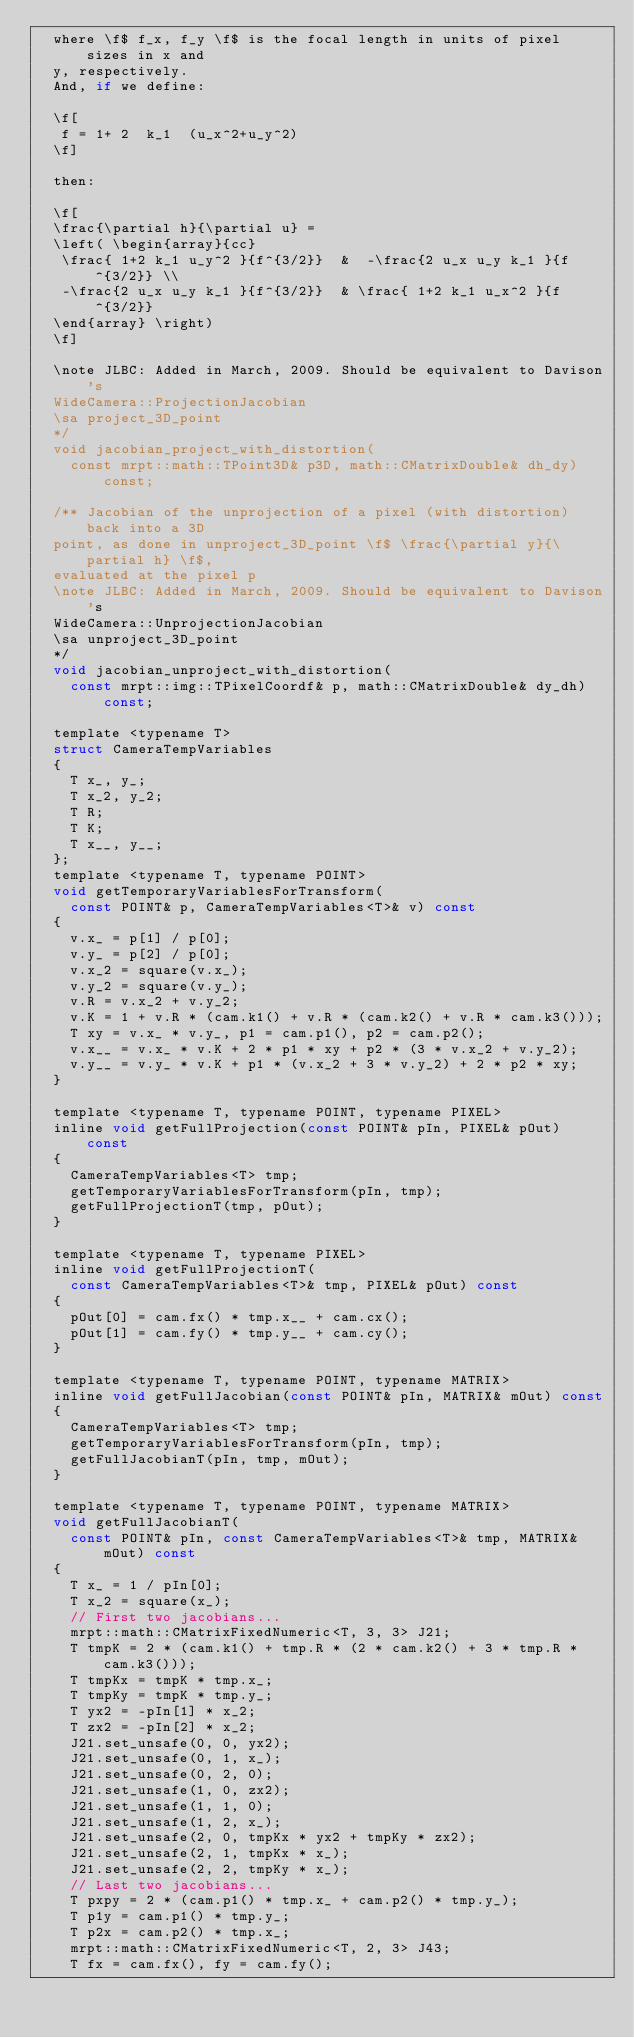Convert code to text. <code><loc_0><loc_0><loc_500><loc_500><_C_>	where \f$ f_x, f_y \f$ is the focal length in units of pixel sizes in x and
	y, respectively.
	And, if we define:

	\f[
	 f = 1+ 2  k_1  (u_x^2+u_y^2)
	\f]

	then:

	\f[
	\frac{\partial h}{\partial u} =
	\left( \begin{array}{cc}
	 \frac{ 1+2 k_1 u_y^2 }{f^{3/2}}  &  -\frac{2 u_x u_y k_1 }{f^{3/2}} \\
	 -\frac{2 u_x u_y k_1 }{f^{3/2}}  & \frac{ 1+2 k_1 u_x^2 }{f^{3/2}}
	\end{array} \right)
	\f]

	\note JLBC: Added in March, 2009. Should be equivalent to Davison's
	WideCamera::ProjectionJacobian
	\sa project_3D_point
	*/
	void jacobian_project_with_distortion(
		const mrpt::math::TPoint3D& p3D, math::CMatrixDouble& dh_dy) const;

	/** Jacobian of the unprojection of a pixel (with distortion) back into a 3D
	point, as done in unproject_3D_point \f$ \frac{\partial y}{\partial h} \f$,
	evaluated at the pixel p
	\note JLBC: Added in March, 2009. Should be equivalent to Davison's
	WideCamera::UnprojectionJacobian
	\sa unproject_3D_point
	*/
	void jacobian_unproject_with_distortion(
		const mrpt::img::TPixelCoordf& p, math::CMatrixDouble& dy_dh) const;

	template <typename T>
	struct CameraTempVariables
	{
		T x_, y_;
		T x_2, y_2;
		T R;
		T K;
		T x__, y__;
	};
	template <typename T, typename POINT>
	void getTemporaryVariablesForTransform(
		const POINT& p, CameraTempVariables<T>& v) const
	{
		v.x_ = p[1] / p[0];
		v.y_ = p[2] / p[0];
		v.x_2 = square(v.x_);
		v.y_2 = square(v.y_);
		v.R = v.x_2 + v.y_2;
		v.K = 1 + v.R * (cam.k1() + v.R * (cam.k2() + v.R * cam.k3()));
		T xy = v.x_ * v.y_, p1 = cam.p1(), p2 = cam.p2();
		v.x__ = v.x_ * v.K + 2 * p1 * xy + p2 * (3 * v.x_2 + v.y_2);
		v.y__ = v.y_ * v.K + p1 * (v.x_2 + 3 * v.y_2) + 2 * p2 * xy;
	}

	template <typename T, typename POINT, typename PIXEL>
	inline void getFullProjection(const POINT& pIn, PIXEL& pOut) const
	{
		CameraTempVariables<T> tmp;
		getTemporaryVariablesForTransform(pIn, tmp);
		getFullProjectionT(tmp, pOut);
	}

	template <typename T, typename PIXEL>
	inline void getFullProjectionT(
		const CameraTempVariables<T>& tmp, PIXEL& pOut) const
	{
		pOut[0] = cam.fx() * tmp.x__ + cam.cx();
		pOut[1] = cam.fy() * tmp.y__ + cam.cy();
	}

	template <typename T, typename POINT, typename MATRIX>
	inline void getFullJacobian(const POINT& pIn, MATRIX& mOut) const
	{
		CameraTempVariables<T> tmp;
		getTemporaryVariablesForTransform(pIn, tmp);
		getFullJacobianT(pIn, tmp, mOut);
	}

	template <typename T, typename POINT, typename MATRIX>
	void getFullJacobianT(
		const POINT& pIn, const CameraTempVariables<T>& tmp, MATRIX& mOut) const
	{
		T x_ = 1 / pIn[0];
		T x_2 = square(x_);
		// First two jacobians...
		mrpt::math::CMatrixFixedNumeric<T, 3, 3> J21;
		T tmpK = 2 * (cam.k1() + tmp.R * (2 * cam.k2() + 3 * tmp.R * cam.k3()));
		T tmpKx = tmpK * tmp.x_;
		T tmpKy = tmpK * tmp.y_;
		T yx2 = -pIn[1] * x_2;
		T zx2 = -pIn[2] * x_2;
		J21.set_unsafe(0, 0, yx2);
		J21.set_unsafe(0, 1, x_);
		J21.set_unsafe(0, 2, 0);
		J21.set_unsafe(1, 0, zx2);
		J21.set_unsafe(1, 1, 0);
		J21.set_unsafe(1, 2, x_);
		J21.set_unsafe(2, 0, tmpKx * yx2 + tmpKy * zx2);
		J21.set_unsafe(2, 1, tmpKx * x_);
		J21.set_unsafe(2, 2, tmpKy * x_);
		// Last two jacobians...
		T pxpy = 2 * (cam.p1() * tmp.x_ + cam.p2() * tmp.y_);
		T p1y = cam.p1() * tmp.y_;
		T p2x = cam.p2() * tmp.x_;
		mrpt::math::CMatrixFixedNumeric<T, 2, 3> J43;
		T fx = cam.fx(), fy = cam.fy();</code> 